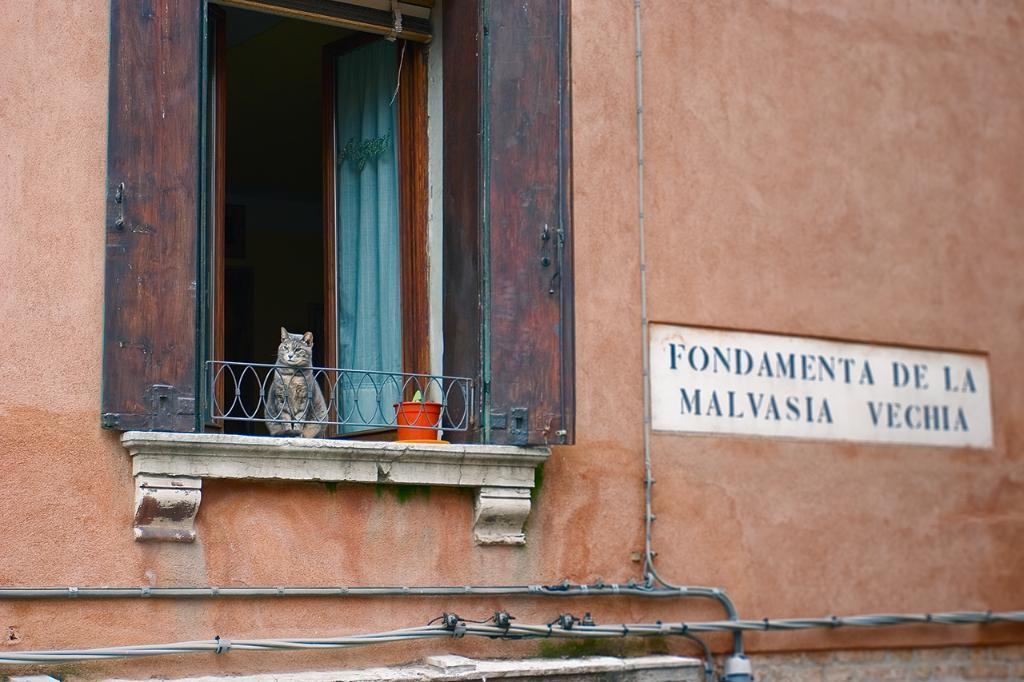How would you summarize this image in a sentence or two? This image consists of a building. In the front, we can see a window along with the curtains. And there is a cat sitting. Beside that, there is a small pot. On the right, we can see a name board. At the bottom, there are wires. 